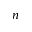<formula> <loc_0><loc_0><loc_500><loc_500>n</formula> 